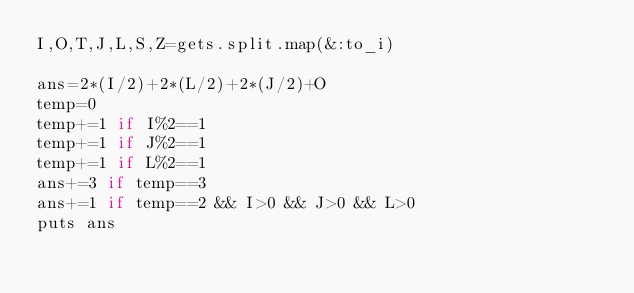<code> <loc_0><loc_0><loc_500><loc_500><_Ruby_>I,O,T,J,L,S,Z=gets.split.map(&:to_i)

ans=2*(I/2)+2*(L/2)+2*(J/2)+O
temp=0
temp+=1 if I%2==1
temp+=1 if J%2==1
temp+=1 if L%2==1
ans+=3 if temp==3
ans+=1 if temp==2 && I>0 && J>0 && L>0
puts ans
</code> 